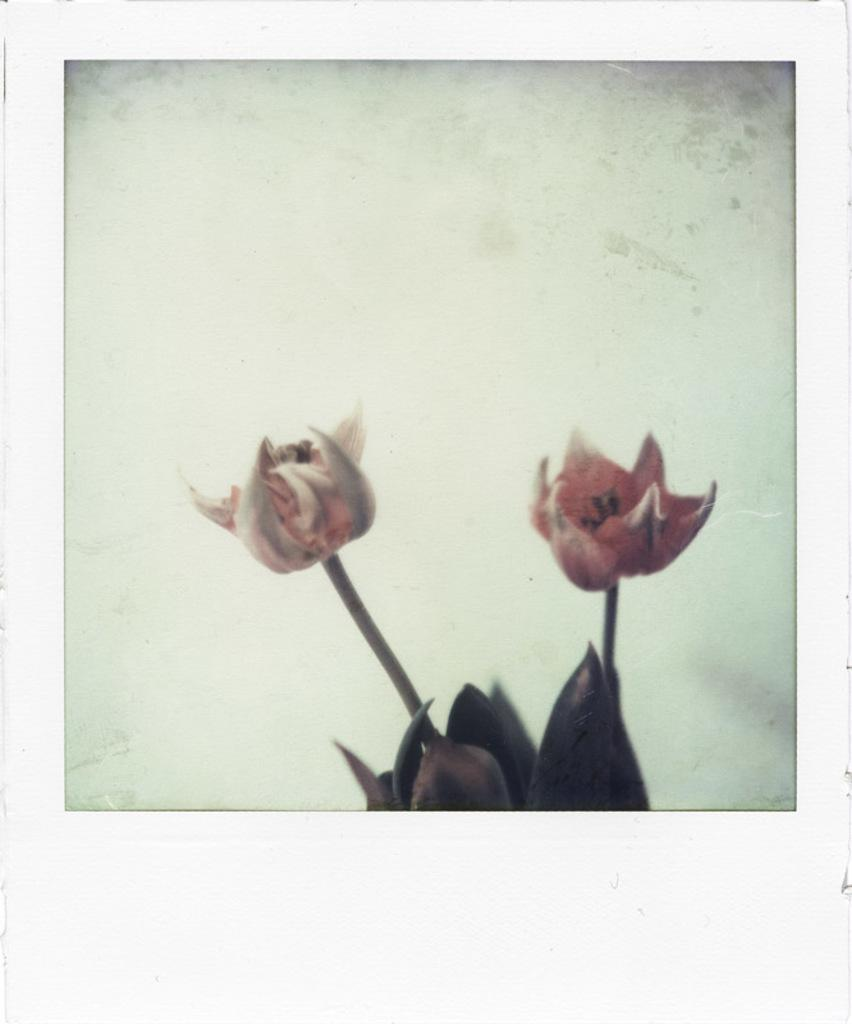What color is the background of the image? The background of the image is white. What type of objects can be seen in the image? There are flowers in the image. Can you describe the flowers in more detail? The flowers have stems and leaves. What type of popcorn is being served at the zoo in the image? There is no popcorn or zoo present in the image; it features flowers with stems and leaves against a white background. 